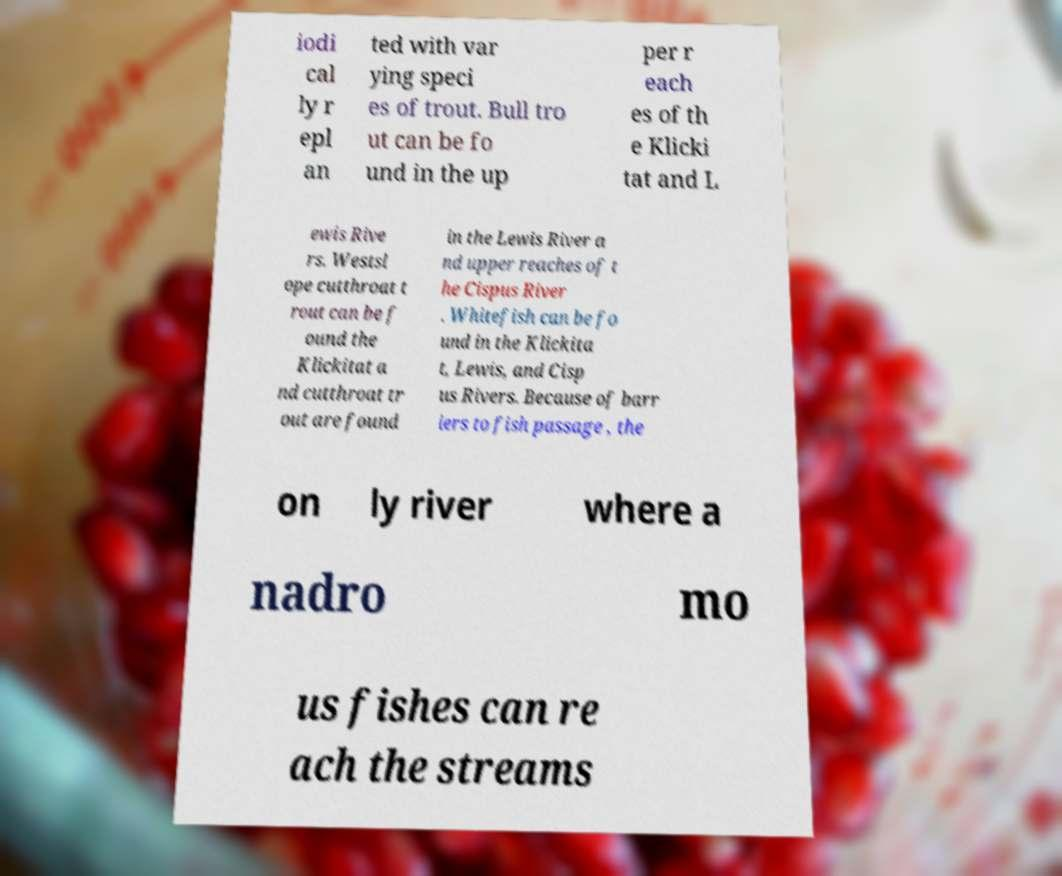Could you extract and type out the text from this image? iodi cal ly r epl an ted with var ying speci es of trout. Bull tro ut can be fo und in the up per r each es of th e Klicki tat and L ewis Rive rs. Westsl ope cutthroat t rout can be f ound the Klickitat a nd cutthroat tr out are found in the Lewis River a nd upper reaches of t he Cispus River . Whitefish can be fo und in the Klickita t, Lewis, and Cisp us Rivers. Because of barr iers to fish passage , the on ly river where a nadro mo us fishes can re ach the streams 